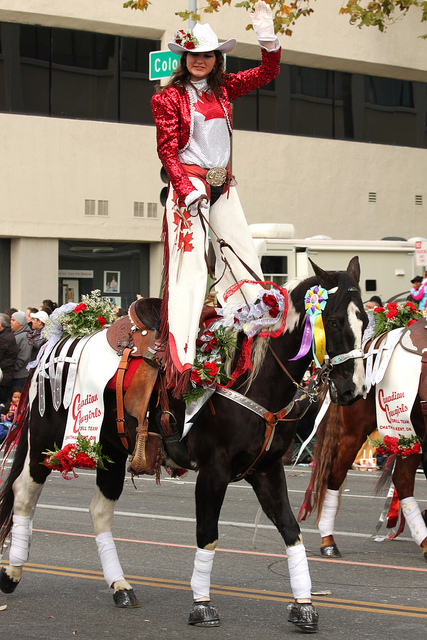Tell me more about the person riding the horse. The person atop the horse is wearing a distinctive outfit that includes a red jacket with shiny sequins, a white shirt, and a white cowboy hat. They're also wearing gloves and posing with one arm raised in a waving gesture. The attire and the decorated horse suggest that they may be part of a parade or a ceremonial event. 